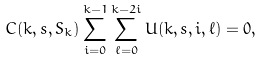Convert formula to latex. <formula><loc_0><loc_0><loc_500><loc_500>C ( k , s , S _ { k } ) \sum _ { i = 0 } ^ { k - 1 } \sum _ { \ell = 0 } ^ { k - 2 i } U ( k , s , i , \ell ) = 0 ,</formula> 